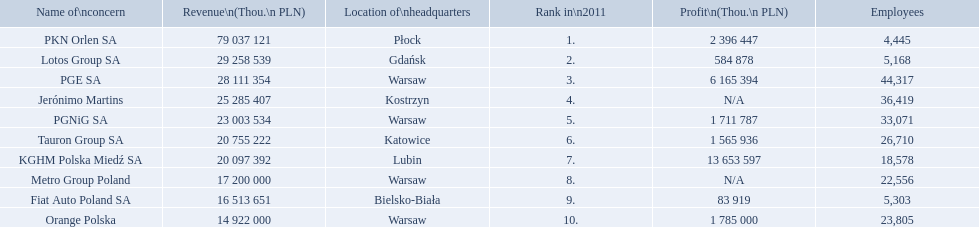What company has 28 111 354 thou.in revenue? PGE SA. What revenue does lotus group sa have? 29 258 539. Who has the next highest revenue than lotus group sa? PKN Orlen SA. 